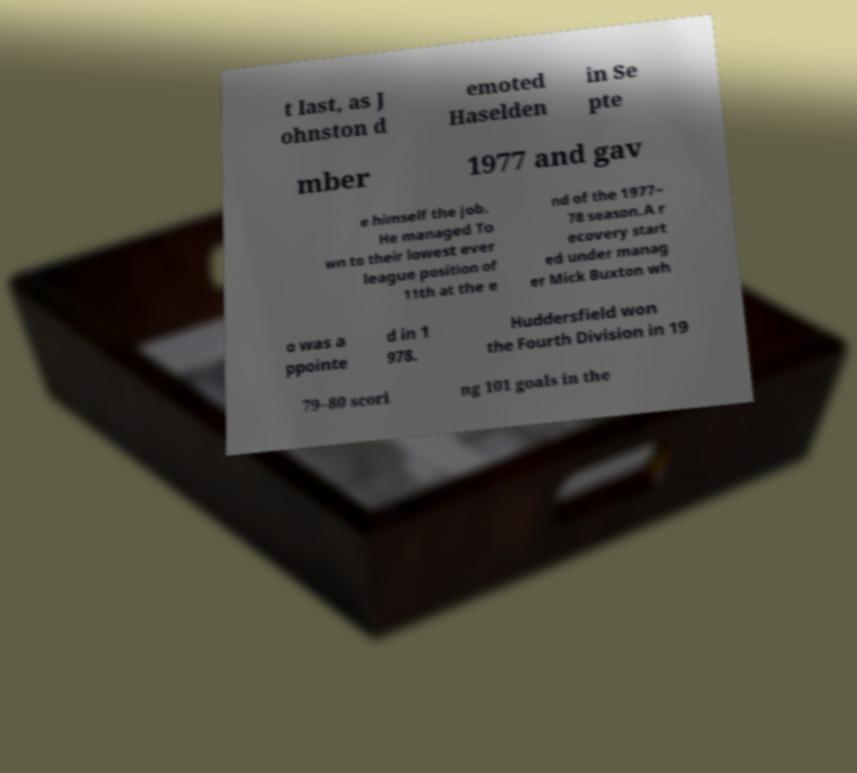I need the written content from this picture converted into text. Can you do that? t last, as J ohnston d emoted Haselden in Se pte mber 1977 and gav e himself the job. He managed To wn to their lowest ever league position of 11th at the e nd of the 1977– 78 season.A r ecovery start ed under manag er Mick Buxton wh o was a ppointe d in 1 978. Huddersfield won the Fourth Division in 19 79–80 scori ng 101 goals in the 